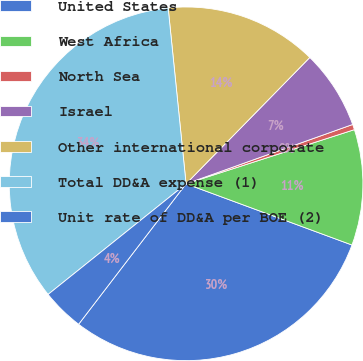Convert chart. <chart><loc_0><loc_0><loc_500><loc_500><pie_chart><fcel>United States<fcel>West Africa<fcel>North Sea<fcel>Israel<fcel>Other international corporate<fcel>Total DD&A expense (1)<fcel>Unit rate of DD&A per BOE (2)<nl><fcel>29.77%<fcel>10.58%<fcel>0.49%<fcel>7.22%<fcel>13.95%<fcel>34.14%<fcel>3.85%<nl></chart> 